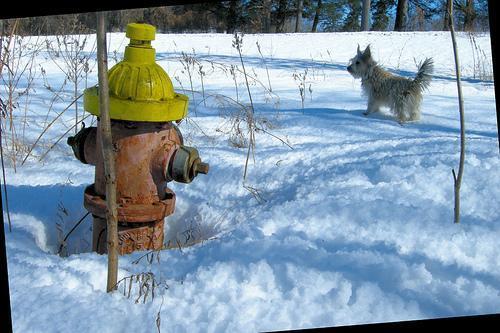How many fire hydrants are there?
Give a very brief answer. 1. 